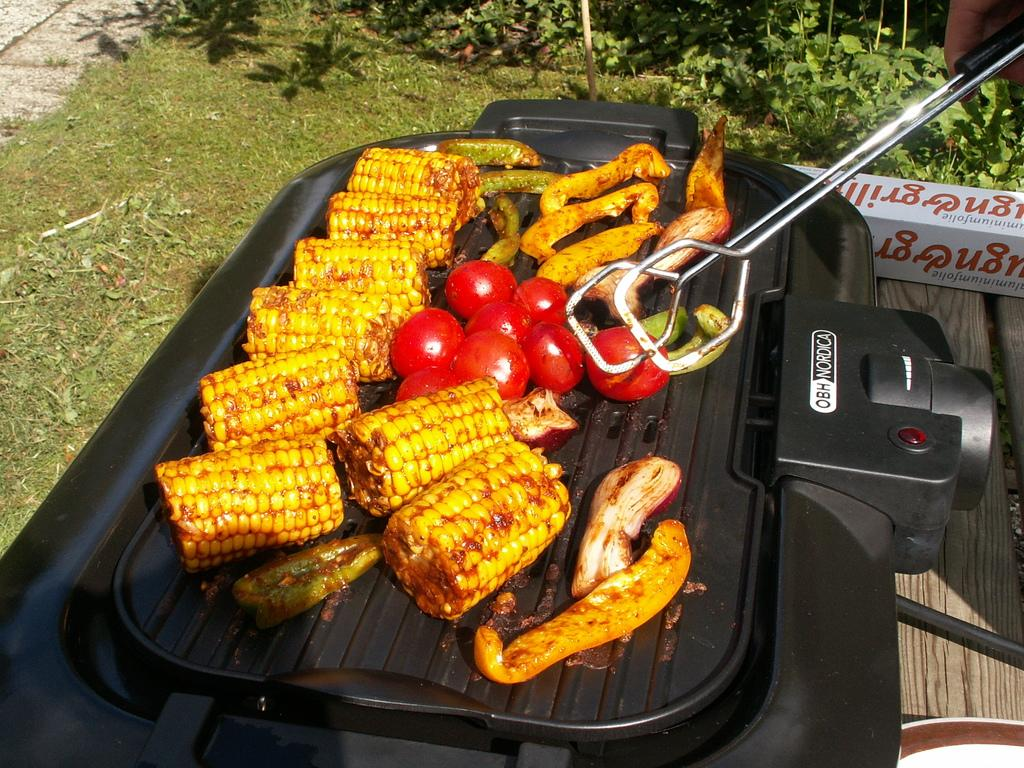Provide a one-sentence caption for the provided image. Someone is cooking vegetables on a OBH Nordica grill. 